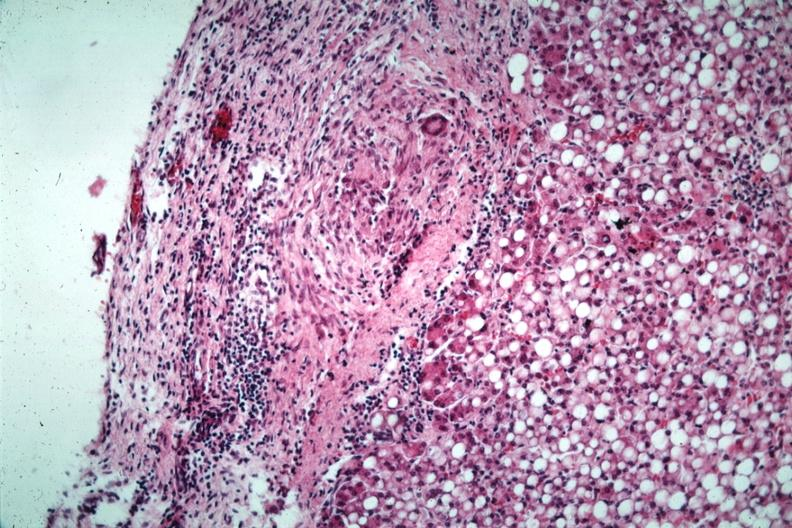s tuberculous peritonitis present?
Answer the question using a single word or phrase. No 